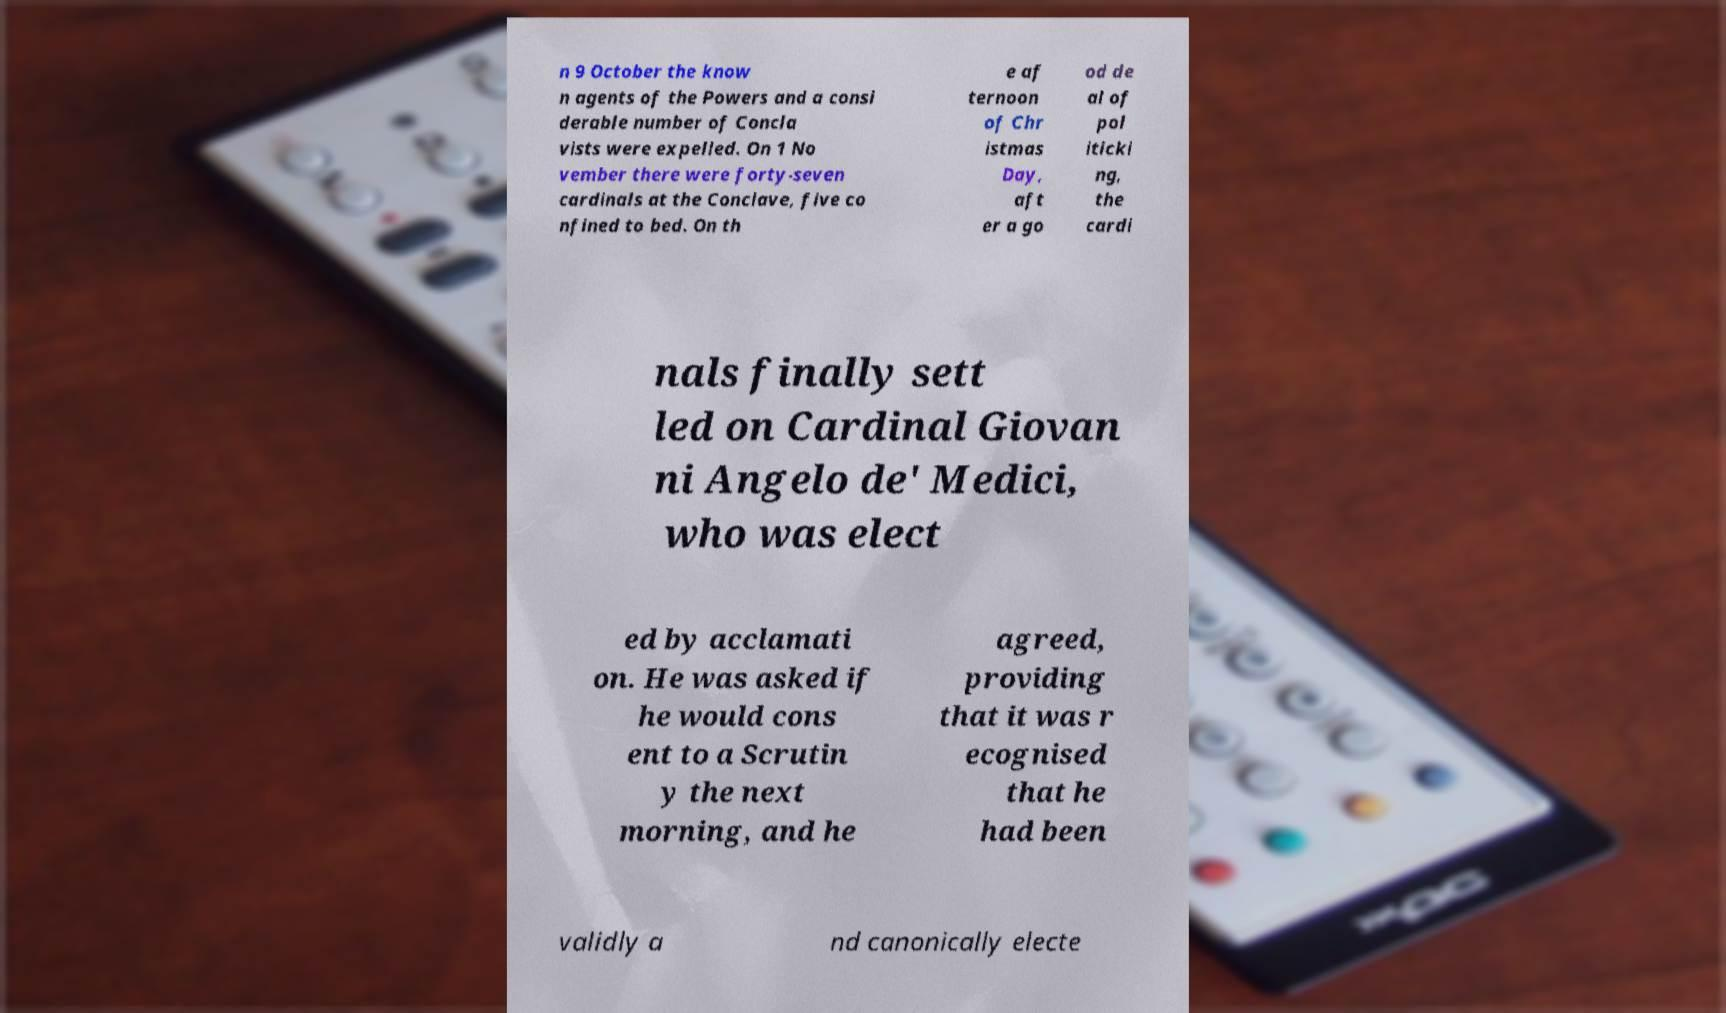I need the written content from this picture converted into text. Can you do that? n 9 October the know n agents of the Powers and a consi derable number of Concla vists were expelled. On 1 No vember there were forty-seven cardinals at the Conclave, five co nfined to bed. On th e af ternoon of Chr istmas Day, aft er a go od de al of pol iticki ng, the cardi nals finally sett led on Cardinal Giovan ni Angelo de' Medici, who was elect ed by acclamati on. He was asked if he would cons ent to a Scrutin y the next morning, and he agreed, providing that it was r ecognised that he had been validly a nd canonically electe 